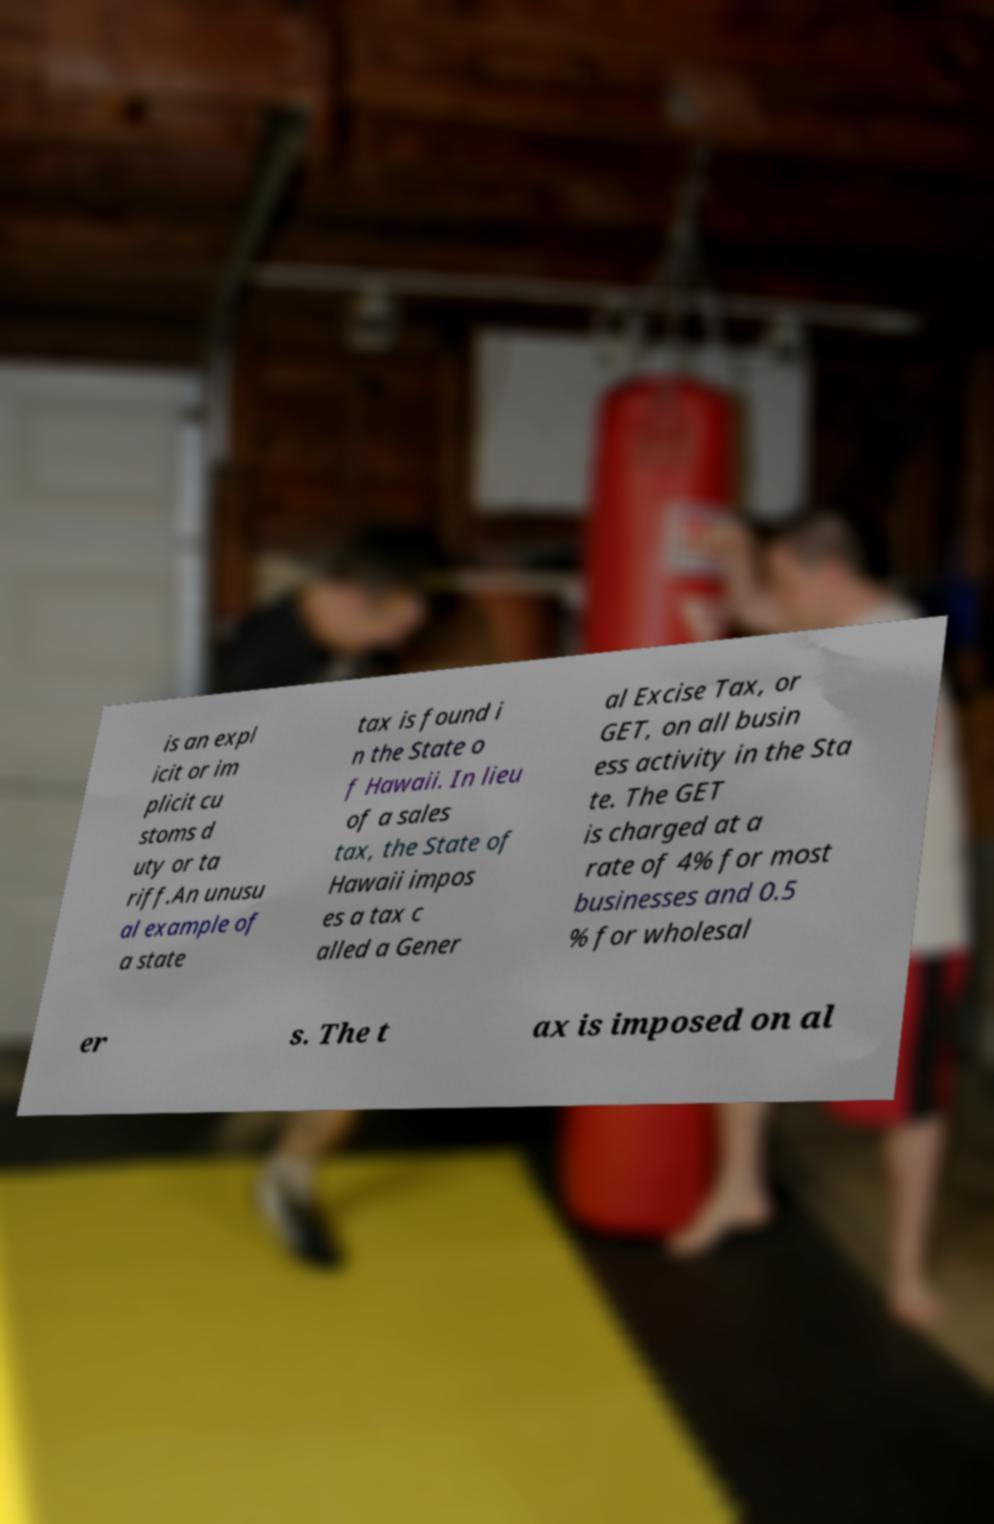Could you assist in decoding the text presented in this image and type it out clearly? is an expl icit or im plicit cu stoms d uty or ta riff.An unusu al example of a state tax is found i n the State o f Hawaii. In lieu of a sales tax, the State of Hawaii impos es a tax c alled a Gener al Excise Tax, or GET, on all busin ess activity in the Sta te. The GET is charged at a rate of 4% for most businesses and 0.5 % for wholesal er s. The t ax is imposed on al 